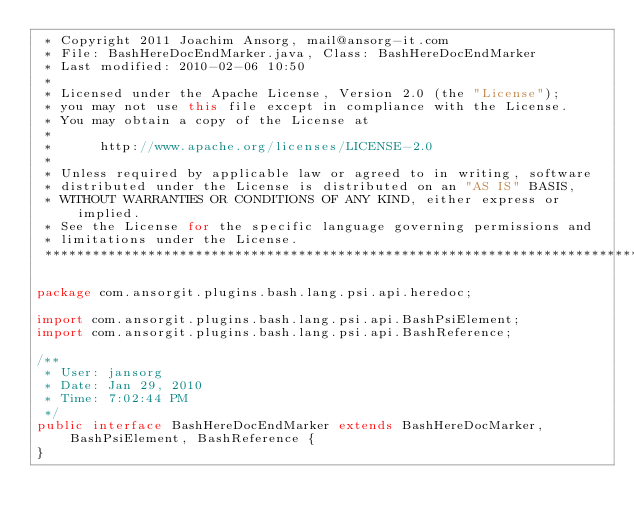Convert code to text. <code><loc_0><loc_0><loc_500><loc_500><_Java_> * Copyright 2011 Joachim Ansorg, mail@ansorg-it.com
 * File: BashHereDocEndMarker.java, Class: BashHereDocEndMarker
 * Last modified: 2010-02-06 10:50
 *
 * Licensed under the Apache License, Version 2.0 (the "License");
 * you may not use this file except in compliance with the License.
 * You may obtain a copy of the License at
 *
 *      http://www.apache.org/licenses/LICENSE-2.0
 *
 * Unless required by applicable law or agreed to in writing, software
 * distributed under the License is distributed on an "AS IS" BASIS,
 * WITHOUT WARRANTIES OR CONDITIONS OF ANY KIND, either express or implied.
 * See the License for the specific language governing permissions and
 * limitations under the License.
 ******************************************************************************/

package com.ansorgit.plugins.bash.lang.psi.api.heredoc;

import com.ansorgit.plugins.bash.lang.psi.api.BashPsiElement;
import com.ansorgit.plugins.bash.lang.psi.api.BashReference;

/**
 * User: jansorg
 * Date: Jan 29, 2010
 * Time: 7:02:44 PM
 */
public interface BashHereDocEndMarker extends BashHereDocMarker, BashPsiElement, BashReference {
}</code> 